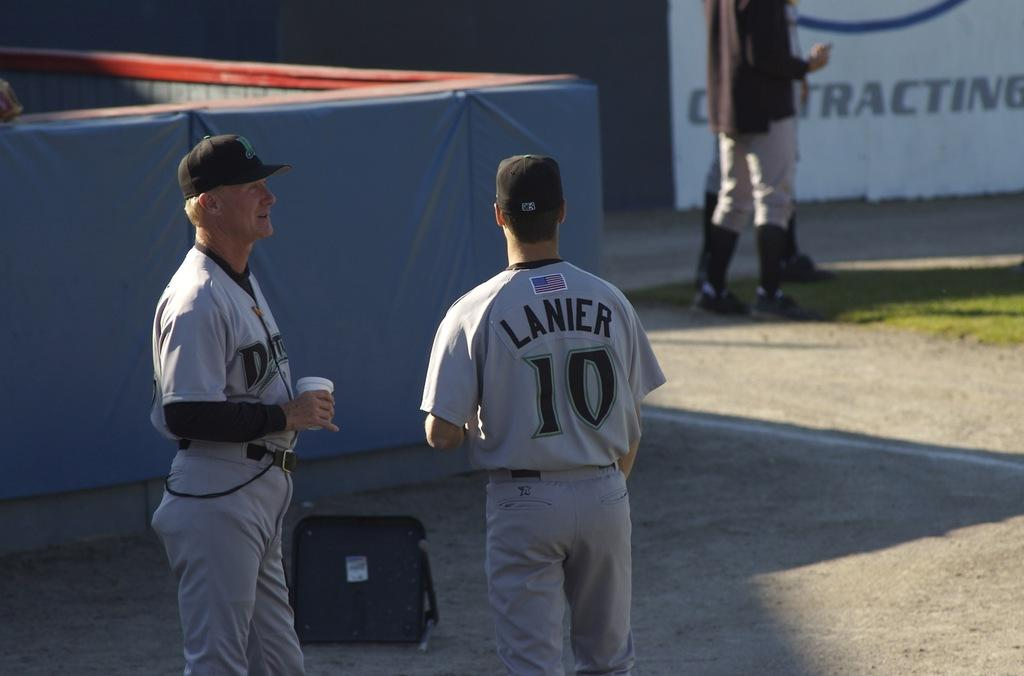<image>
Provide a brief description of the given image. Two baseball players stand talking to each other, one of them in a uniform that says "Lanier 10." 